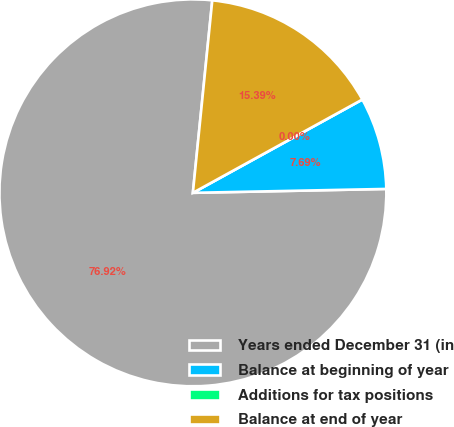<chart> <loc_0><loc_0><loc_500><loc_500><pie_chart><fcel>Years ended December 31 (in<fcel>Balance at beginning of year<fcel>Additions for tax positions<fcel>Balance at end of year<nl><fcel>76.92%<fcel>7.69%<fcel>0.0%<fcel>15.39%<nl></chart> 